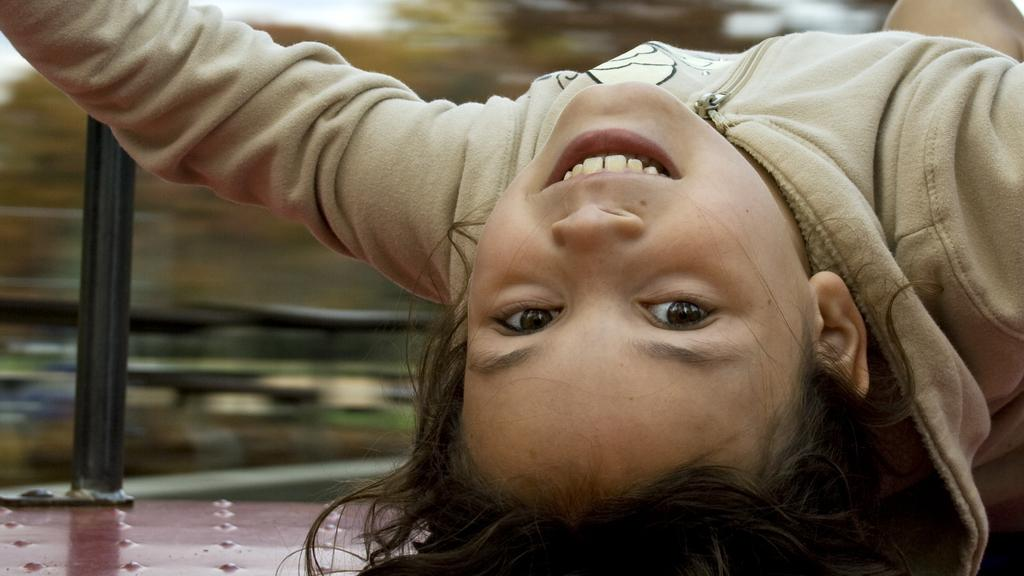What is the main subject of the picture? The main subject of the picture is a child. What is the child doing in the picture? The child is laying on a platform. What is located beside the child? There is a pole beside the child. What is the child's facial expression in the picture? The child is smiling. What type of clothing is the child wearing? The child is wearing a jacket. What type of plane can be seen flying in the background of the image? There is no plane visible in the background of the image. What kind of club is the child holding in the picture? There is no club present in the image. 